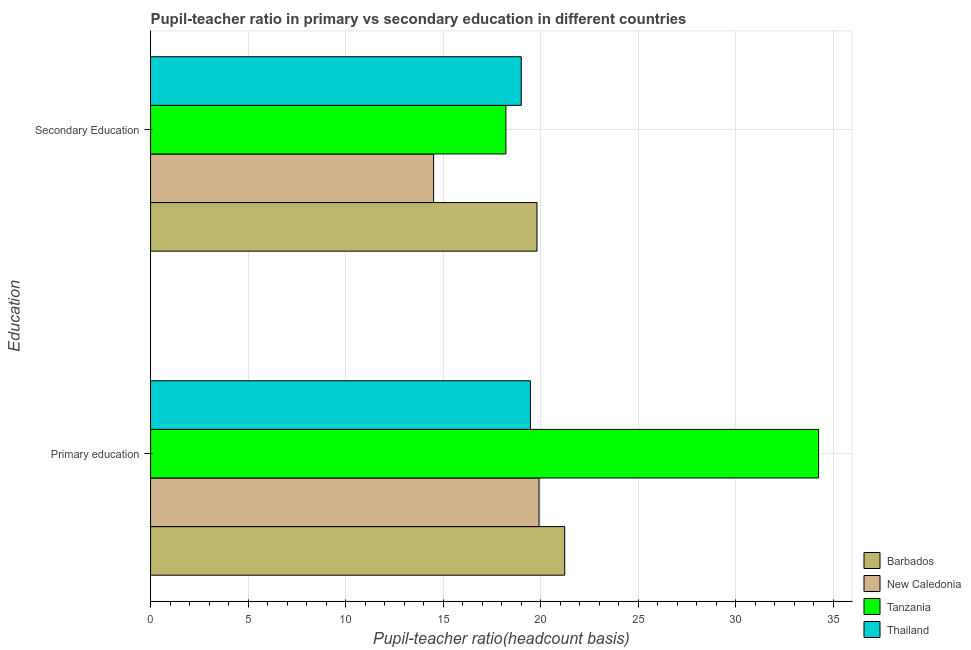Are the number of bars on each tick of the Y-axis equal?
Your response must be concise. Yes. What is the label of the 1st group of bars from the top?
Offer a terse response. Secondary Education. What is the pupil-teacher ratio in primary education in Barbados?
Your answer should be very brief. 21.23. Across all countries, what is the maximum pupil-teacher ratio in primary education?
Offer a very short reply. 34.24. Across all countries, what is the minimum pupil-teacher ratio in primary education?
Your answer should be very brief. 19.47. In which country was the pupil teacher ratio on secondary education maximum?
Provide a short and direct response. Barbados. In which country was the pupil-teacher ratio in primary education minimum?
Your answer should be compact. Thailand. What is the total pupil teacher ratio on secondary education in the graph?
Offer a terse response. 71.52. What is the difference between the pupil-teacher ratio in primary education in Barbados and that in Tanzania?
Your answer should be very brief. -13.01. What is the difference between the pupil-teacher ratio in primary education in New Caledonia and the pupil teacher ratio on secondary education in Tanzania?
Keep it short and to the point. 1.7. What is the average pupil teacher ratio on secondary education per country?
Provide a succinct answer. 17.88. What is the difference between the pupil teacher ratio on secondary education and pupil-teacher ratio in primary education in New Caledonia?
Keep it short and to the point. -5.4. In how many countries, is the pupil teacher ratio on secondary education greater than 32 ?
Keep it short and to the point. 0. What is the ratio of the pupil-teacher ratio in primary education in Tanzania to that in Thailand?
Your answer should be very brief. 1.76. Is the pupil-teacher ratio in primary education in Tanzania less than that in New Caledonia?
Your response must be concise. No. What does the 1st bar from the top in Secondary Education represents?
Make the answer very short. Thailand. What does the 3rd bar from the bottom in Secondary Education represents?
Keep it short and to the point. Tanzania. Are all the bars in the graph horizontal?
Offer a very short reply. Yes. How many countries are there in the graph?
Your answer should be very brief. 4. What is the difference between two consecutive major ticks on the X-axis?
Provide a short and direct response. 5. Does the graph contain any zero values?
Give a very brief answer. No. Does the graph contain grids?
Make the answer very short. Yes. Where does the legend appear in the graph?
Your answer should be compact. Bottom right. What is the title of the graph?
Your answer should be very brief. Pupil-teacher ratio in primary vs secondary education in different countries. What is the label or title of the X-axis?
Offer a terse response. Pupil-teacher ratio(headcount basis). What is the label or title of the Y-axis?
Your answer should be compact. Education. What is the Pupil-teacher ratio(headcount basis) in Barbados in Primary education?
Make the answer very short. 21.23. What is the Pupil-teacher ratio(headcount basis) of New Caledonia in Primary education?
Offer a very short reply. 19.91. What is the Pupil-teacher ratio(headcount basis) of Tanzania in Primary education?
Offer a very short reply. 34.24. What is the Pupil-teacher ratio(headcount basis) in Thailand in Primary education?
Keep it short and to the point. 19.47. What is the Pupil-teacher ratio(headcount basis) of Barbados in Secondary Education?
Keep it short and to the point. 19.8. What is the Pupil-teacher ratio(headcount basis) of New Caledonia in Secondary Education?
Provide a succinct answer. 14.51. What is the Pupil-teacher ratio(headcount basis) of Tanzania in Secondary Education?
Offer a terse response. 18.21. What is the Pupil-teacher ratio(headcount basis) in Thailand in Secondary Education?
Your answer should be very brief. 19. Across all Education, what is the maximum Pupil-teacher ratio(headcount basis) of Barbados?
Provide a short and direct response. 21.23. Across all Education, what is the maximum Pupil-teacher ratio(headcount basis) of New Caledonia?
Provide a succinct answer. 19.91. Across all Education, what is the maximum Pupil-teacher ratio(headcount basis) of Tanzania?
Offer a terse response. 34.24. Across all Education, what is the maximum Pupil-teacher ratio(headcount basis) of Thailand?
Ensure brevity in your answer.  19.47. Across all Education, what is the minimum Pupil-teacher ratio(headcount basis) in Barbados?
Provide a short and direct response. 19.8. Across all Education, what is the minimum Pupil-teacher ratio(headcount basis) in New Caledonia?
Provide a short and direct response. 14.51. Across all Education, what is the minimum Pupil-teacher ratio(headcount basis) of Tanzania?
Give a very brief answer. 18.21. Across all Education, what is the minimum Pupil-teacher ratio(headcount basis) of Thailand?
Provide a short and direct response. 19. What is the total Pupil-teacher ratio(headcount basis) in Barbados in the graph?
Make the answer very short. 41.03. What is the total Pupil-teacher ratio(headcount basis) of New Caledonia in the graph?
Keep it short and to the point. 34.42. What is the total Pupil-teacher ratio(headcount basis) of Tanzania in the graph?
Your response must be concise. 52.45. What is the total Pupil-teacher ratio(headcount basis) in Thailand in the graph?
Your answer should be very brief. 38.47. What is the difference between the Pupil-teacher ratio(headcount basis) of Barbados in Primary education and that in Secondary Education?
Give a very brief answer. 1.42. What is the difference between the Pupil-teacher ratio(headcount basis) in New Caledonia in Primary education and that in Secondary Education?
Your response must be concise. 5.4. What is the difference between the Pupil-teacher ratio(headcount basis) in Tanzania in Primary education and that in Secondary Education?
Ensure brevity in your answer.  16.03. What is the difference between the Pupil-teacher ratio(headcount basis) in Thailand in Primary education and that in Secondary Education?
Your answer should be compact. 0.47. What is the difference between the Pupil-teacher ratio(headcount basis) of Barbados in Primary education and the Pupil-teacher ratio(headcount basis) of New Caledonia in Secondary Education?
Provide a succinct answer. 6.72. What is the difference between the Pupil-teacher ratio(headcount basis) of Barbados in Primary education and the Pupil-teacher ratio(headcount basis) of Tanzania in Secondary Education?
Keep it short and to the point. 3.01. What is the difference between the Pupil-teacher ratio(headcount basis) of Barbados in Primary education and the Pupil-teacher ratio(headcount basis) of Thailand in Secondary Education?
Give a very brief answer. 2.23. What is the difference between the Pupil-teacher ratio(headcount basis) of New Caledonia in Primary education and the Pupil-teacher ratio(headcount basis) of Tanzania in Secondary Education?
Your answer should be compact. 1.7. What is the difference between the Pupil-teacher ratio(headcount basis) in New Caledonia in Primary education and the Pupil-teacher ratio(headcount basis) in Thailand in Secondary Education?
Your answer should be compact. 0.91. What is the difference between the Pupil-teacher ratio(headcount basis) in Tanzania in Primary education and the Pupil-teacher ratio(headcount basis) in Thailand in Secondary Education?
Provide a succinct answer. 15.24. What is the average Pupil-teacher ratio(headcount basis) in Barbados per Education?
Make the answer very short. 20.51. What is the average Pupil-teacher ratio(headcount basis) of New Caledonia per Education?
Your answer should be very brief. 17.21. What is the average Pupil-teacher ratio(headcount basis) of Tanzania per Education?
Your answer should be compact. 26.22. What is the average Pupil-teacher ratio(headcount basis) of Thailand per Education?
Keep it short and to the point. 19.23. What is the difference between the Pupil-teacher ratio(headcount basis) of Barbados and Pupil-teacher ratio(headcount basis) of New Caledonia in Primary education?
Keep it short and to the point. 1.32. What is the difference between the Pupil-teacher ratio(headcount basis) of Barbados and Pupil-teacher ratio(headcount basis) of Tanzania in Primary education?
Keep it short and to the point. -13.01. What is the difference between the Pupil-teacher ratio(headcount basis) of Barbados and Pupil-teacher ratio(headcount basis) of Thailand in Primary education?
Your answer should be compact. 1.76. What is the difference between the Pupil-teacher ratio(headcount basis) in New Caledonia and Pupil-teacher ratio(headcount basis) in Tanzania in Primary education?
Your answer should be very brief. -14.33. What is the difference between the Pupil-teacher ratio(headcount basis) of New Caledonia and Pupil-teacher ratio(headcount basis) of Thailand in Primary education?
Provide a short and direct response. 0.44. What is the difference between the Pupil-teacher ratio(headcount basis) of Tanzania and Pupil-teacher ratio(headcount basis) of Thailand in Primary education?
Your answer should be compact. 14.77. What is the difference between the Pupil-teacher ratio(headcount basis) in Barbados and Pupil-teacher ratio(headcount basis) in New Caledonia in Secondary Education?
Your answer should be very brief. 5.3. What is the difference between the Pupil-teacher ratio(headcount basis) of Barbados and Pupil-teacher ratio(headcount basis) of Tanzania in Secondary Education?
Your answer should be compact. 1.59. What is the difference between the Pupil-teacher ratio(headcount basis) of Barbados and Pupil-teacher ratio(headcount basis) of Thailand in Secondary Education?
Provide a short and direct response. 0.81. What is the difference between the Pupil-teacher ratio(headcount basis) in New Caledonia and Pupil-teacher ratio(headcount basis) in Tanzania in Secondary Education?
Give a very brief answer. -3.7. What is the difference between the Pupil-teacher ratio(headcount basis) in New Caledonia and Pupil-teacher ratio(headcount basis) in Thailand in Secondary Education?
Provide a short and direct response. -4.49. What is the difference between the Pupil-teacher ratio(headcount basis) of Tanzania and Pupil-teacher ratio(headcount basis) of Thailand in Secondary Education?
Your answer should be very brief. -0.79. What is the ratio of the Pupil-teacher ratio(headcount basis) of Barbados in Primary education to that in Secondary Education?
Offer a terse response. 1.07. What is the ratio of the Pupil-teacher ratio(headcount basis) in New Caledonia in Primary education to that in Secondary Education?
Provide a short and direct response. 1.37. What is the ratio of the Pupil-teacher ratio(headcount basis) of Tanzania in Primary education to that in Secondary Education?
Provide a succinct answer. 1.88. What is the ratio of the Pupil-teacher ratio(headcount basis) of Thailand in Primary education to that in Secondary Education?
Offer a terse response. 1.02. What is the difference between the highest and the second highest Pupil-teacher ratio(headcount basis) of Barbados?
Offer a terse response. 1.42. What is the difference between the highest and the second highest Pupil-teacher ratio(headcount basis) of New Caledonia?
Offer a very short reply. 5.4. What is the difference between the highest and the second highest Pupil-teacher ratio(headcount basis) in Tanzania?
Ensure brevity in your answer.  16.03. What is the difference between the highest and the second highest Pupil-teacher ratio(headcount basis) of Thailand?
Your answer should be very brief. 0.47. What is the difference between the highest and the lowest Pupil-teacher ratio(headcount basis) in Barbados?
Ensure brevity in your answer.  1.42. What is the difference between the highest and the lowest Pupil-teacher ratio(headcount basis) in New Caledonia?
Your response must be concise. 5.4. What is the difference between the highest and the lowest Pupil-teacher ratio(headcount basis) in Tanzania?
Make the answer very short. 16.03. What is the difference between the highest and the lowest Pupil-teacher ratio(headcount basis) of Thailand?
Your response must be concise. 0.47. 